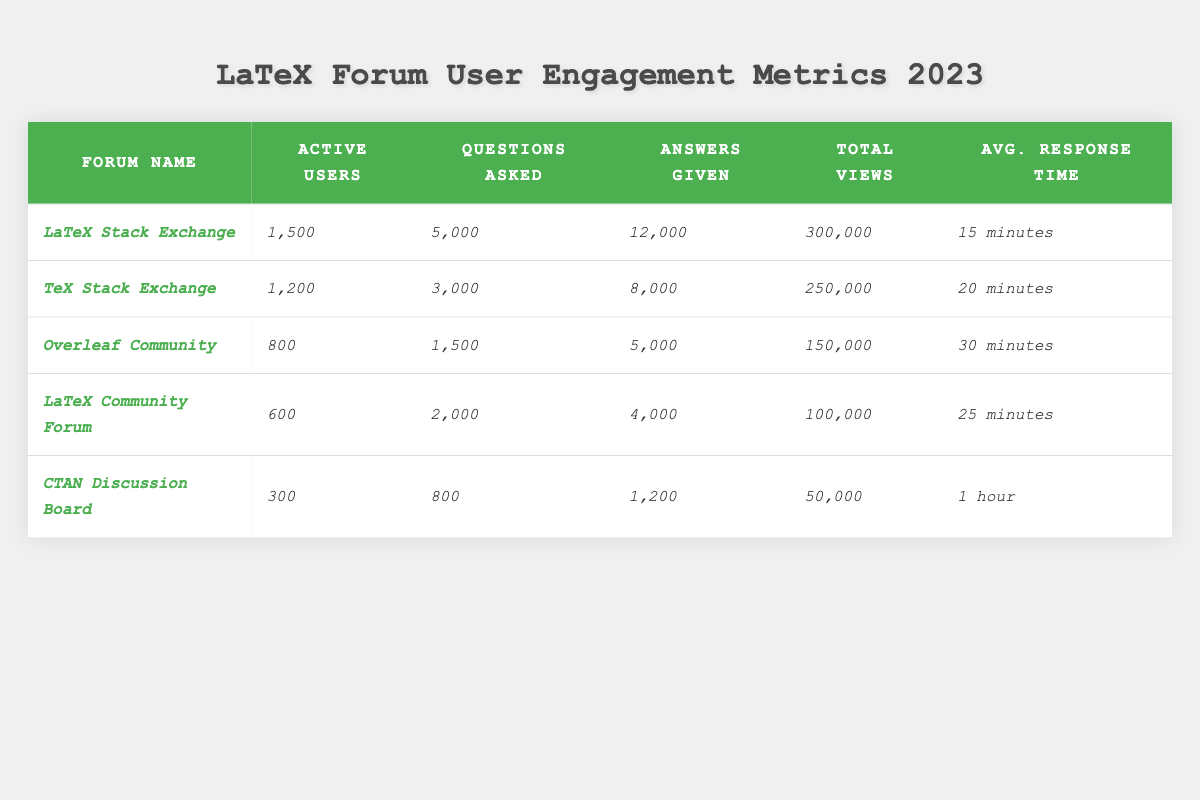What is the forum with the highest number of active users? By looking at the "Active Users" column, we can see that "LaTeX Stack Exchange" has the highest value at 1,500.
Answer: LaTeX Stack Exchange How many total views did the "CTAN Discussion Board" receive? The "Total Views" column shows that the "CTAN Discussion Board" received 50,000 views.
Answer: 50,000 Which forum has the longest average response time? By comparing the "Avg. Response Time" values, we find that "CTAN Discussion Board" has the longest response time of 1 hour.
Answer: CTAN Discussion Board How many more questions were asked in "LaTeX Stack Exchange" than in "Overleaf Community"? "LaTeX Stack Exchange" has 5,000 questions asked, while "Overleaf Community" has 1,500; the difference is 5,000 - 1,500 = 3,500.
Answer: 3,500 What is the total number of answers given across all forums? By summing the values in the "Answers Given" column (12,000 + 8,000 + 5,000 + 4,000 + 1,200), we find the total is 30,200.
Answer: 30,200 Is it true that the "TeX Stack Exchange" has more active users than the "LaTeX Community Forum"? Comparing the "Active Users" of "TeX Stack Exchange" (1,200) and "LaTeX Community Forum" (600), it is true that "TeX Stack Exchange" has more users.
Answer: Yes Which forum had the least questions asked? In the "Questions Asked" column, "CTAN Discussion Board" has the least at 800.
Answer: CTAN Discussion Board What is the average response time for all forums combined? To calculate the average, convert each response time into minutes (15, 20, 30, 25, 60), sum them (15 + 20 + 30 + 25 + 60 = 150), then divide by 5 (the number of forums) resulting in an average of 30 minutes.
Answer: 30 minutes Which forum had the highest total views, and what was the number? The "Total Views" column indicates "LaTeX Stack Exchange" had the highest views at 300,000.
Answer: LaTeX Stack Exchange, 300,000 How many active users do "Overleaf Community" and "LaTeX Community Forum" have together? By adding the active users (800 for "Overleaf Community" and 600 for "LaTeX Community Forum"), we find the total is 800 + 600 = 1,400.
Answer: 1,400 Does the "LaTeX Stack Exchange" have more answers given than the total views of the "CTAN Discussion Board"? "LaTeX Stack Exchange" provided 12,000 answers, which is greater than the 50,000 views of the "CTAN Discussion Board." Thus, this statement is true.
Answer: Yes 